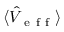Convert formula to latex. <formula><loc_0><loc_0><loc_500><loc_500>\langle \hat { V } _ { e f f } \rangle</formula> 